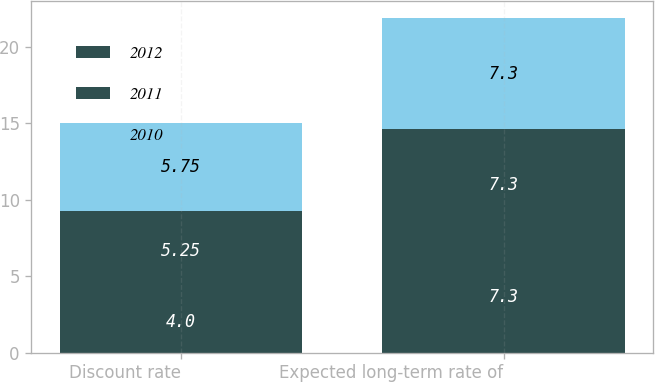Convert chart. <chart><loc_0><loc_0><loc_500><loc_500><stacked_bar_chart><ecel><fcel>Discount rate<fcel>Expected long-term rate of<nl><fcel>2012<fcel>4<fcel>7.3<nl><fcel>2011<fcel>5.25<fcel>7.3<nl><fcel>2010<fcel>5.75<fcel>7.3<nl></chart> 